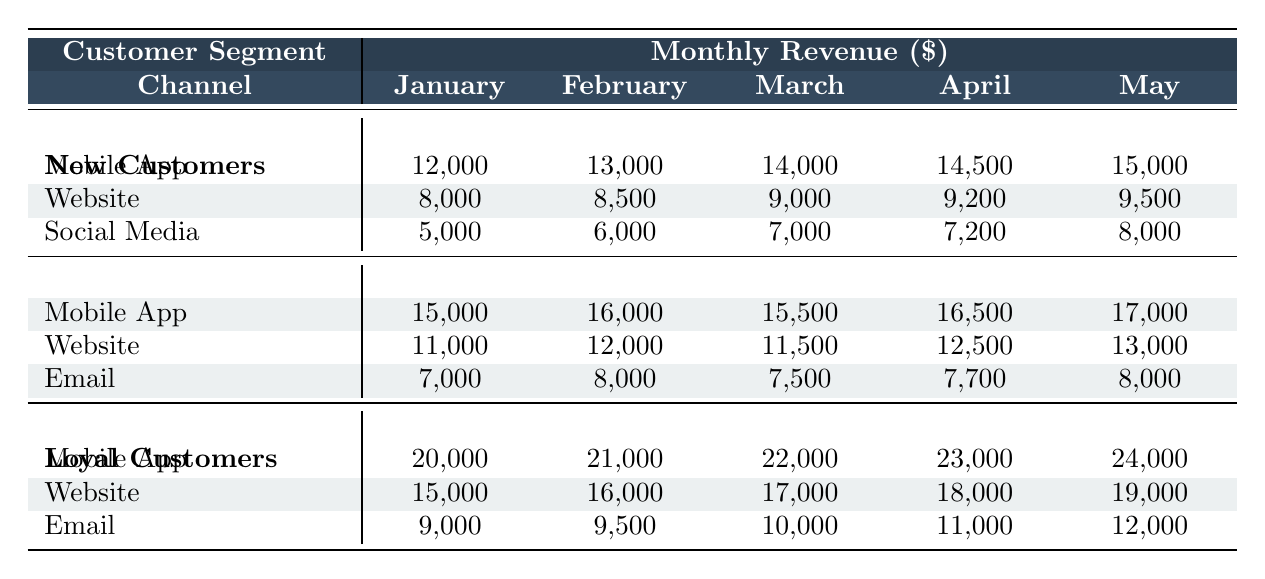What was the revenue from returning customers via the website in February? The table shows the revenue for returning customers under the website channel in February. It indicates the value of 12,000.
Answer: 12,000 Which customer segment generated the highest revenue through the mobile app in March? In the table, we can see that loyal customers generated 22,000 through the mobile app in March, which is higher than the other segments: new customers (14,000) and returning customers (15,500).
Answer: Loyal Customers What is the total revenue from new customers across all channels in April? To find the total revenue from new customers in April, we sum the values: Mobile App (14,500) + Website (9,200) + Social Media (7,200) = 30,900.
Answer: 30,900 Did social media revenue for new customers increase every month from January to May? Looking at the table, social media revenue for new customers was 5,000 in January, 6,000 in February, 7,000 in March, 7,200 in April, and 8,000 in May. The value increased from January to April, and then it increased again in May. Therefore, it did increase every month.
Answer: Yes What was the percentage increase in revenue from returning customers via the mobile app from January to May? The revenue for returning customers via the mobile app was 15,000 in January and increased to 17,000 in May. The difference is 17,000 - 15,000 = 2,000. The percentage increase is (2,000 / 15,000) * 100 = 13.33%.
Answer: 13.33% Which channel contributed the least revenue for new customers in February? By comparing the revenues in the table, we see social media revenue for new customers in February was 6,000, which is less than mobile app (13,000) and website (8,500).
Answer: Social Media What was the average revenue from loyal customers across all channels in May? To calculate the average for loyal customers in May, we sum the revenue: Mobile App (24,000) + Website (19,000) + Email (12,000) = 55,000. Then we divide by the number of channels (3): 55,000 / 3 = 18,333.33.
Answer: 18,333.33 What is the total revenue for returning customers in January? The total revenue for returning customers in January from all channels is: Mobile App (15,000) + Website (11,000) + Email (7,000) = 33,000.
Answer: 33,000 Is there any month where loyal customers earned less revenue through the website than returning customers? By examining the table, we find that loyal customers earned 15,000 in January (website), while returning customers earned 11,000. This trend continues in all months, with loyal customers consistently earning more.
Answer: No What is the difference in total revenue from loyal customers between January and March? For loyal customers, we sum up January (20,000 + 15,000 + 9,000 = 44,000) and March (22,000 + 17,000 + 10,000 = 49,000). The difference is 49,000 - 44,000 = 5,000.
Answer: 5,000 Which customer segment had the highest revenue across all channels in the month of February? In February, loyal customers earned a total of 21,000 (Mobile App) + 16,000 (Website) + 9,500 (Email) = 46,500. This is compared against new customers (38,500) and returning customers (44,000). Thus, returning customers were the highest.
Answer: Returning Customers 